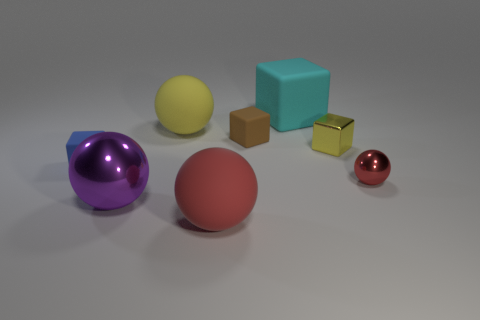What is the color of the large matte ball that is behind the red ball left of the big cyan thing?
Provide a succinct answer. Yellow. What number of objects are the same color as the small shiny block?
Provide a short and direct response. 1. There is a large metal sphere; is it the same color as the large matte thing that is in front of the red shiny sphere?
Offer a terse response. No. Is the number of small blue cubes less than the number of blue rubber cylinders?
Offer a terse response. No. Is the number of small shiny cubes that are on the right side of the small red metal object greater than the number of metal things behind the small metal cube?
Offer a terse response. No. Is the material of the tiny brown block the same as the yellow ball?
Your response must be concise. Yes. What number of red rubber things are in front of the red sphere that is left of the tiny metal ball?
Offer a terse response. 0. Does the small block to the right of the big cyan object have the same color as the big rubber block?
Provide a short and direct response. No. How many things are red metal cubes or small objects to the right of the big metal ball?
Keep it short and to the point. 3. Do the yellow object left of the cyan matte object and the large matte object in front of the tiny yellow thing have the same shape?
Keep it short and to the point. Yes. 